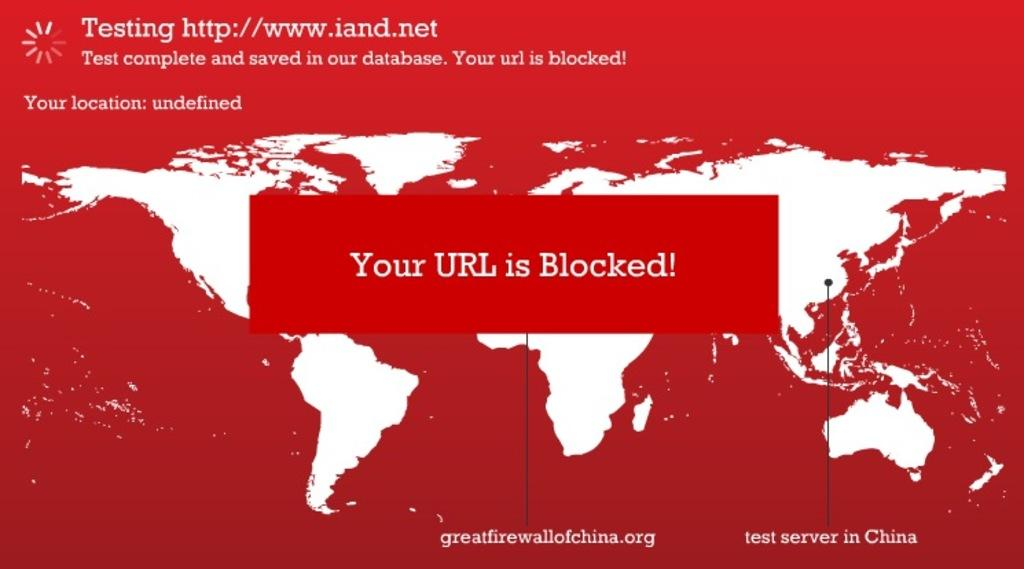<image>
Share a concise interpretation of the image provided. a url was blocked on a test web page 